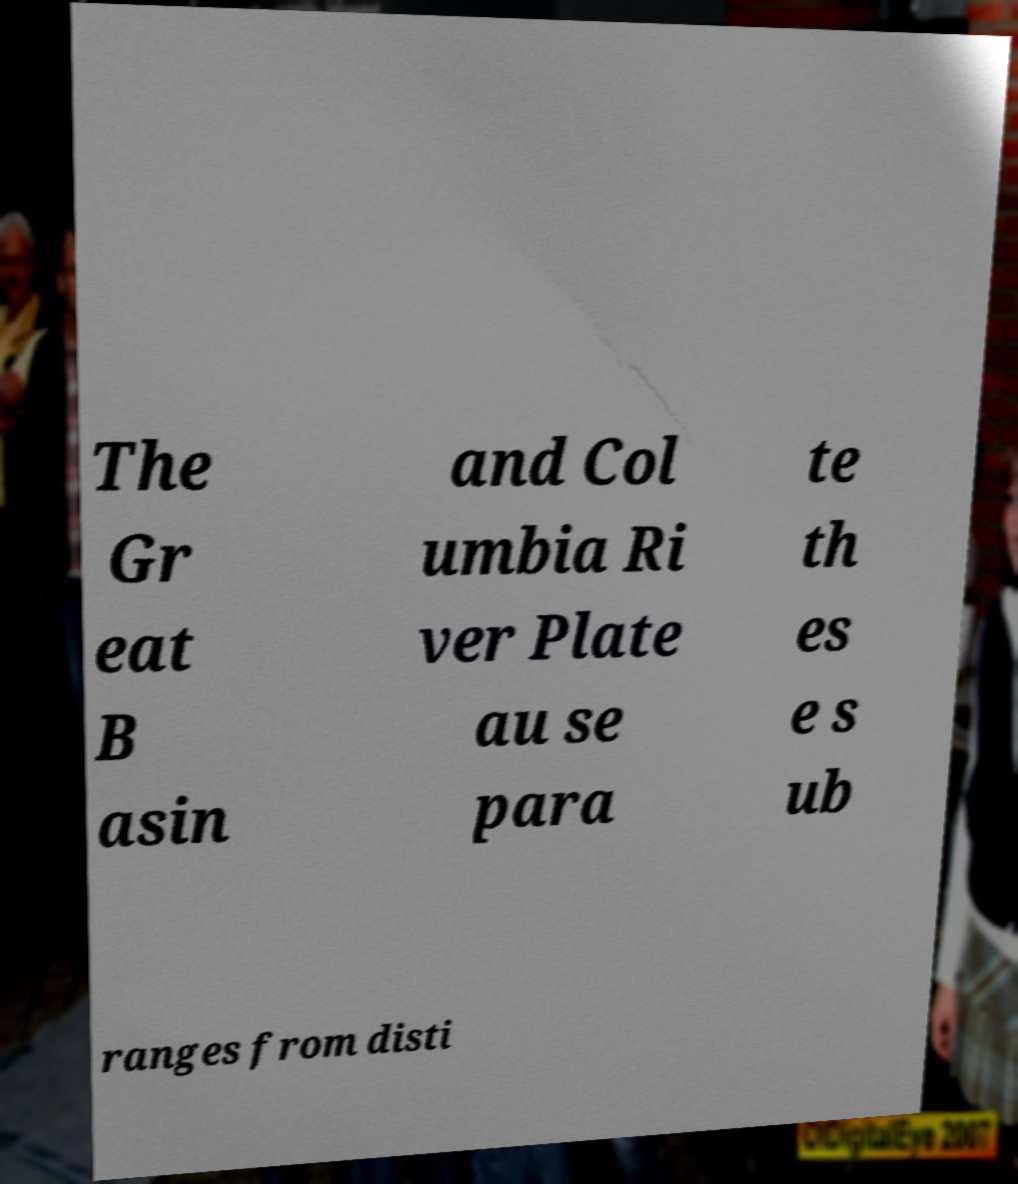Please read and relay the text visible in this image. What does it say? The Gr eat B asin and Col umbia Ri ver Plate au se para te th es e s ub ranges from disti 